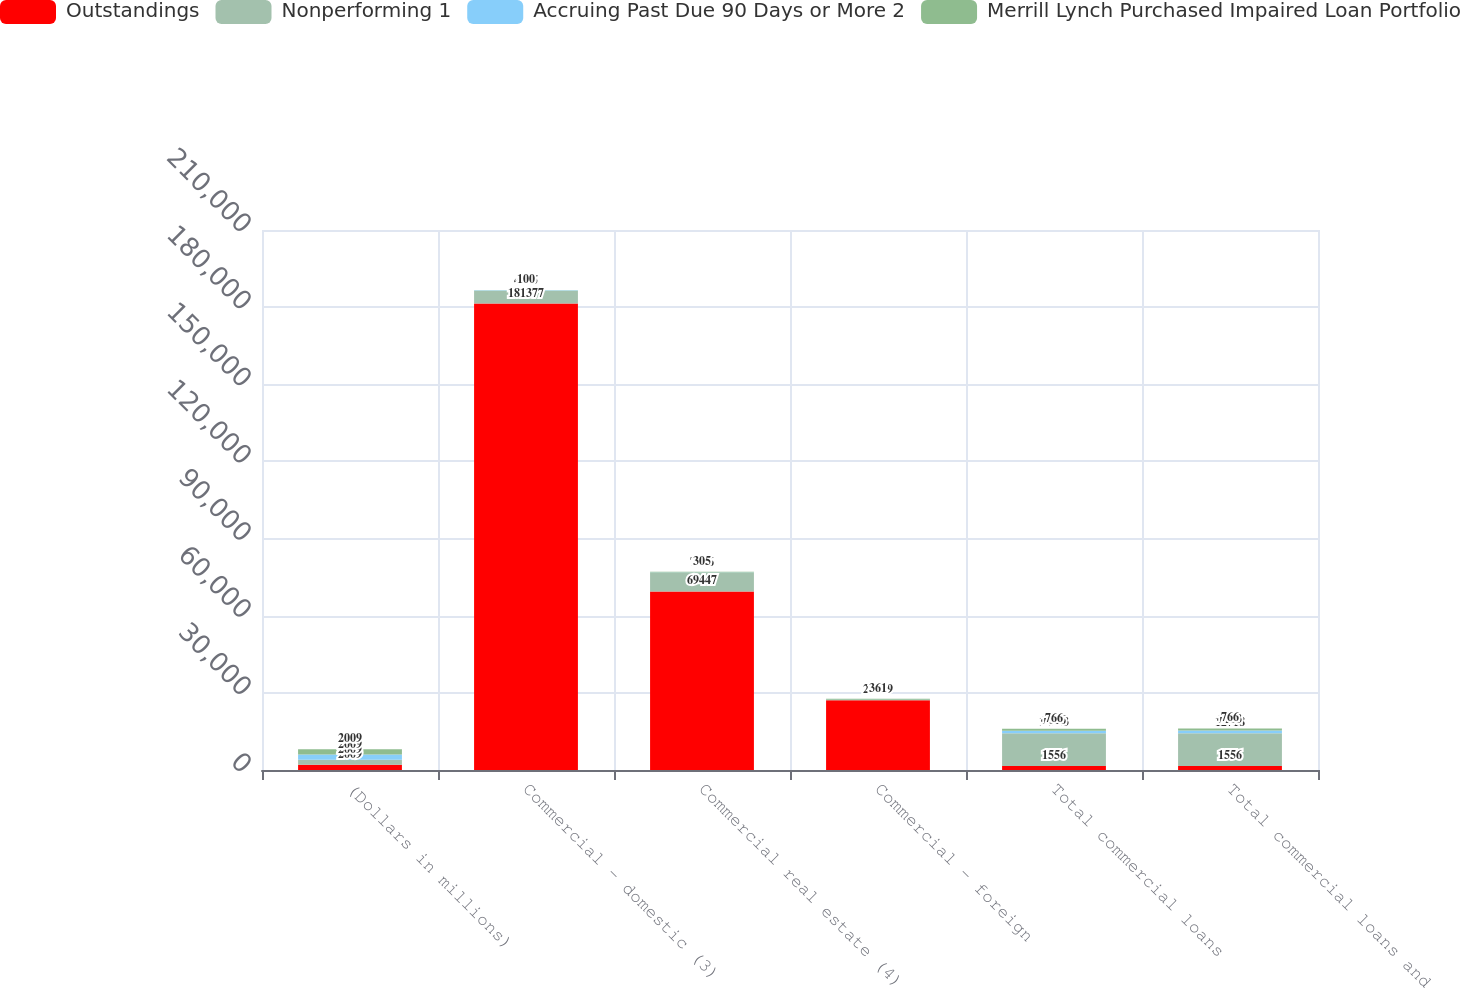Convert chart. <chart><loc_0><loc_0><loc_500><loc_500><stacked_bar_chart><ecel><fcel>(Dollars in millions)<fcel>Commercial - domestic (3)<fcel>Commercial real estate (4)<fcel>Commercial - foreign<fcel>Total commercial loans<fcel>Total commercial loans and<nl><fcel>Outstandings<fcel>2009<fcel>181377<fcel>69447<fcel>27079<fcel>1556<fcel>1556<nl><fcel>Nonperforming 1<fcel>2009<fcel>4925<fcel>7286<fcel>177<fcel>12703<fcel>12718<nl><fcel>Accruing Past Due 90 Days or More 2<fcel>2009<fcel>213<fcel>80<fcel>67<fcel>1016<fcel>1103<nl><fcel>Merrill Lynch Purchased Impaired Loan Portfolio<fcel>2009<fcel>100<fcel>305<fcel>361<fcel>766<fcel>766<nl></chart> 